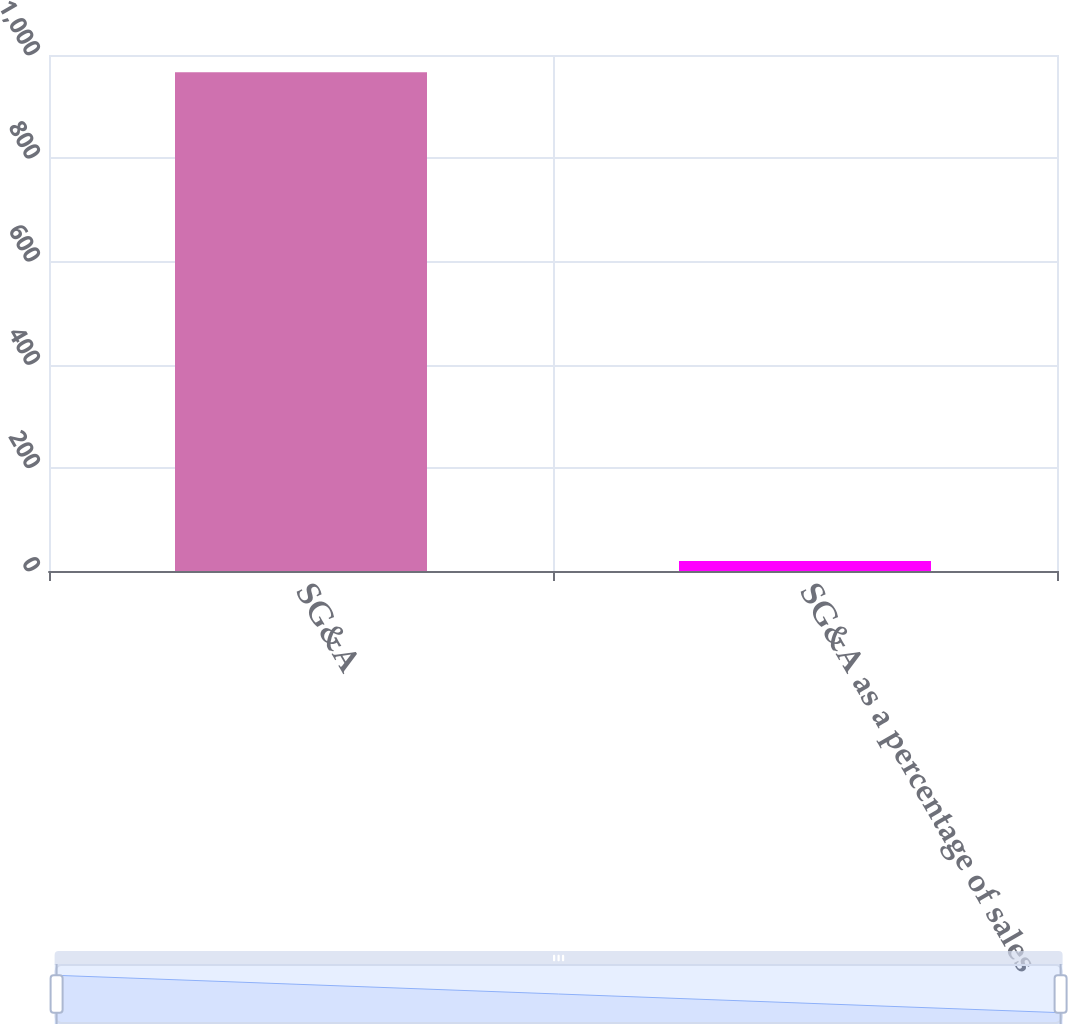Convert chart to OTSL. <chart><loc_0><loc_0><loc_500><loc_500><bar_chart><fcel>SG&A<fcel>SG&A as a percentage of sales<nl><fcel>966.8<fcel>19.5<nl></chart> 